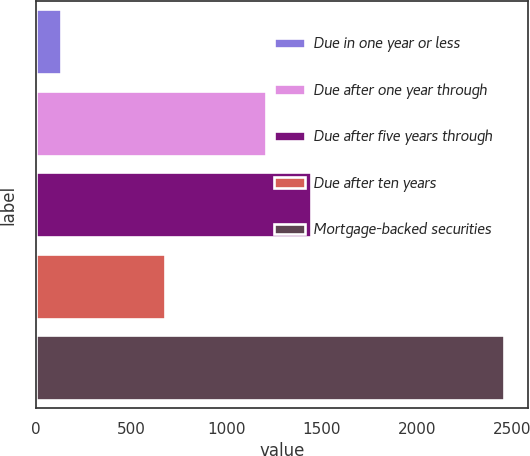<chart> <loc_0><loc_0><loc_500><loc_500><bar_chart><fcel>Due in one year or less<fcel>Due after one year through<fcel>Due after five years through<fcel>Due after ten years<fcel>Mortgage-backed securities<nl><fcel>129.2<fcel>1209.9<fcel>1442.87<fcel>677.7<fcel>2458.9<nl></chart> 